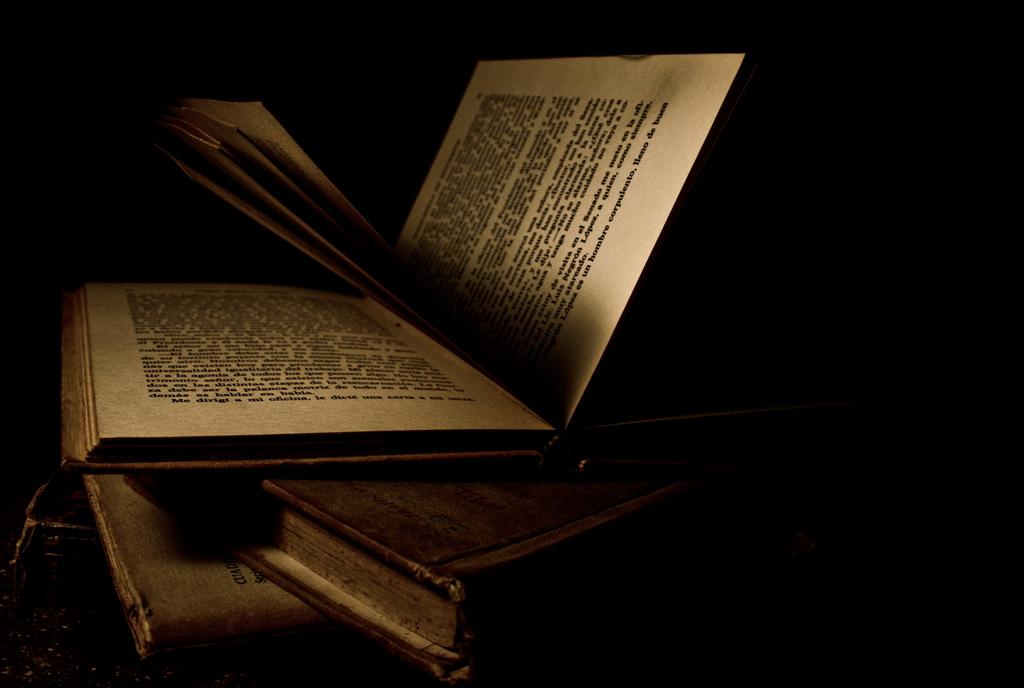<image>
Relay a brief, clear account of the picture shown. A book is open to a page that ends with the word buen. 